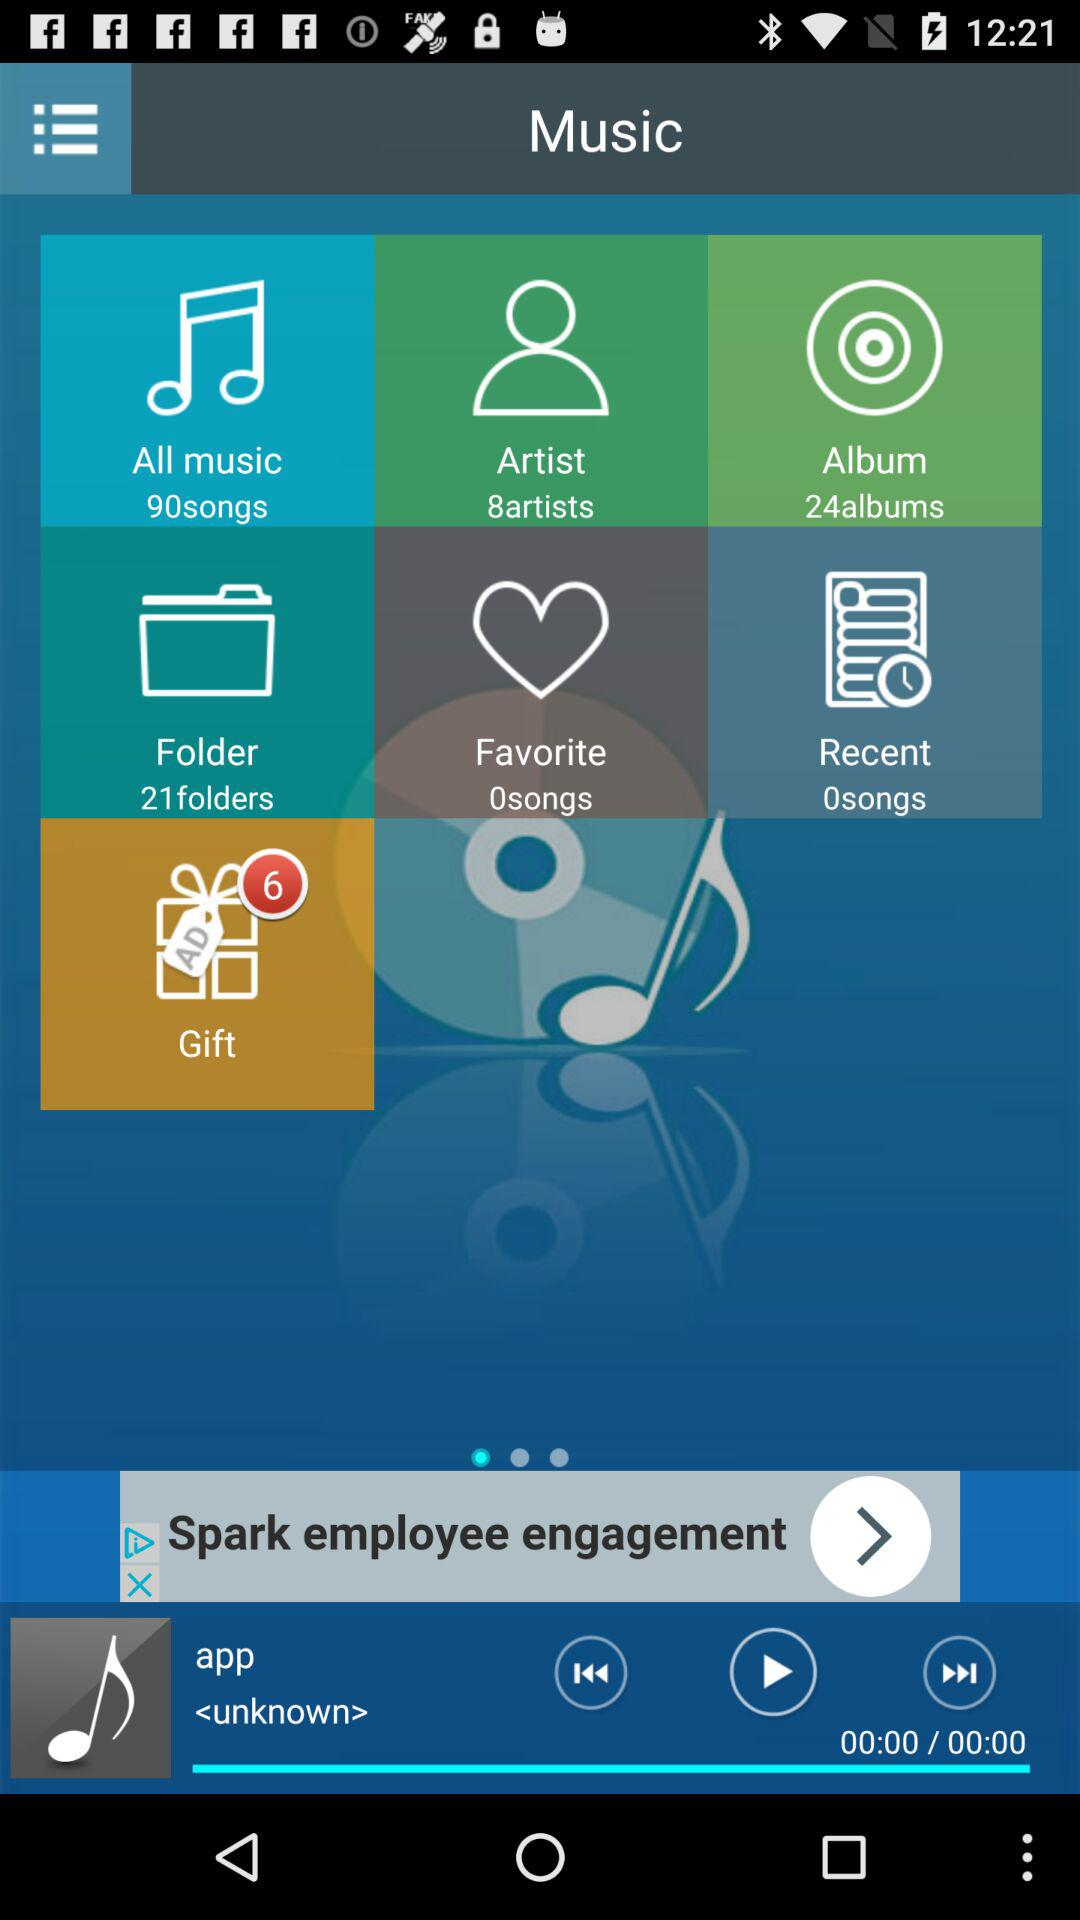Who is the singer of the song which is currently playing? The name of the singer is "unknown". 